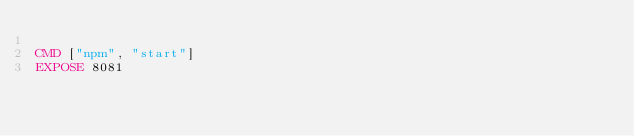Convert code to text. <code><loc_0><loc_0><loc_500><loc_500><_Dockerfile_>
CMD ["npm", "start"]
EXPOSE 8081
</code> 